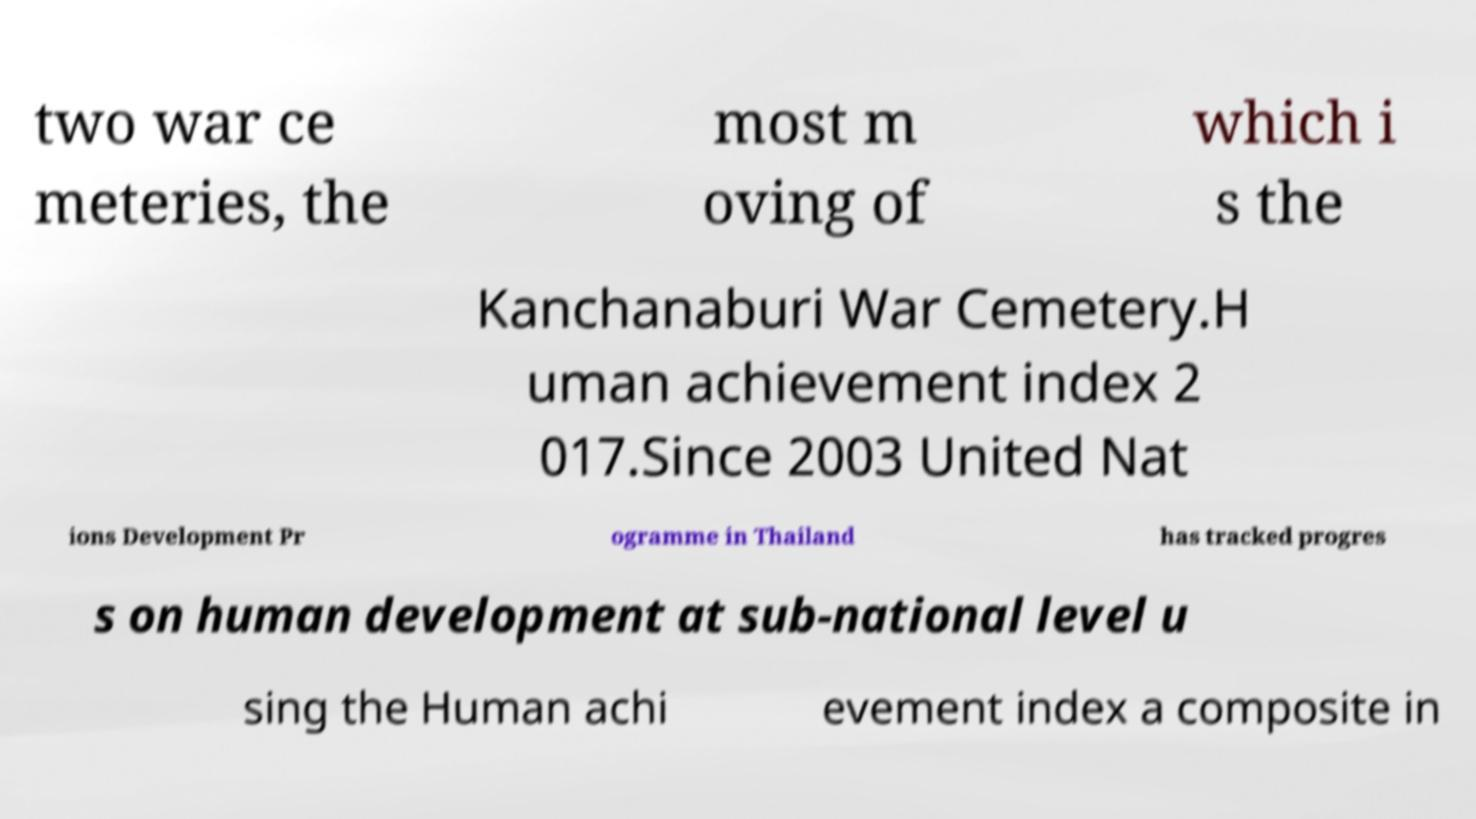Can you accurately transcribe the text from the provided image for me? two war ce meteries, the most m oving of which i s the Kanchanaburi War Cemetery.H uman achievement index 2 017.Since 2003 United Nat ions Development Pr ogramme in Thailand has tracked progres s on human development at sub-national level u sing the Human achi evement index a composite in 